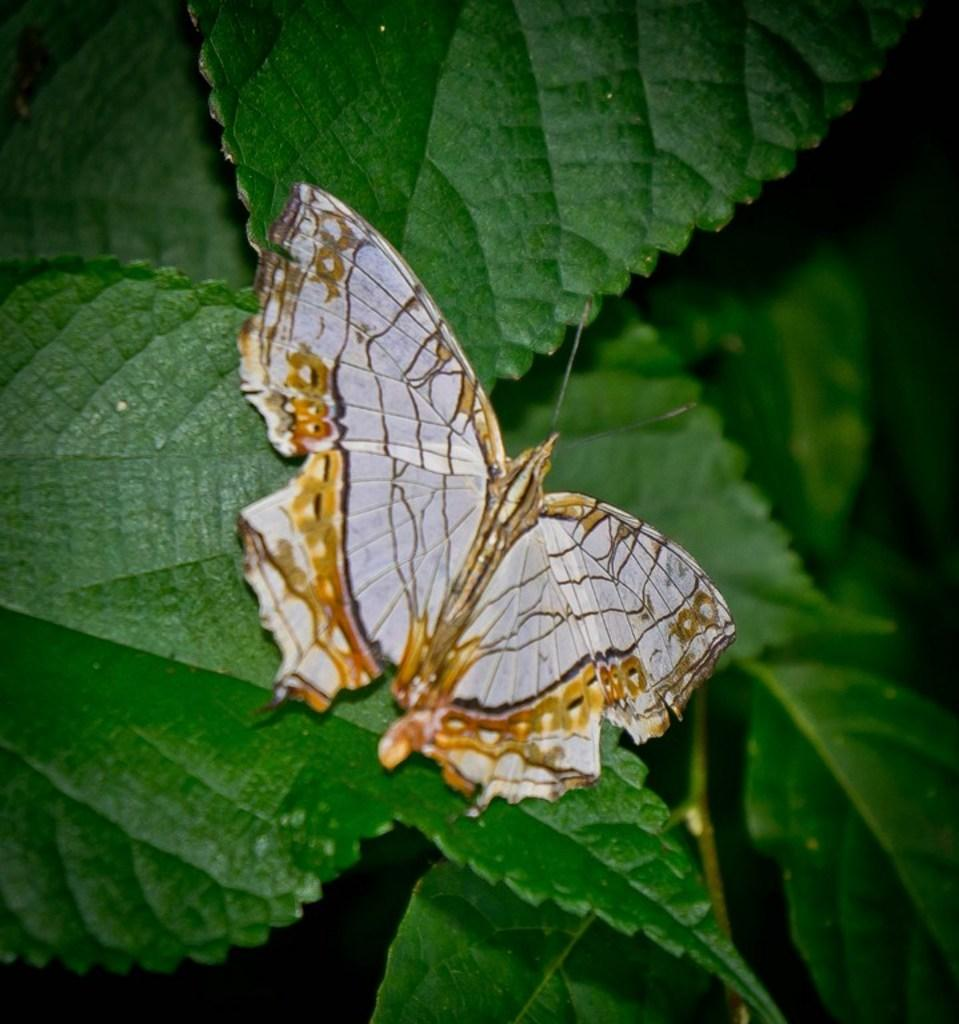What is the main subject of the image? The main subject of the image is a plant with many leaves. Can you describe the plant's appearance? The plant has many leaves in the image. What additional element can be seen in the image? There is a butterfly sitting on one of the leaves. What type of apparel is the butterfly wearing in the image? Butterflies do not wear apparel, so there is no clothing to describe in the image. 